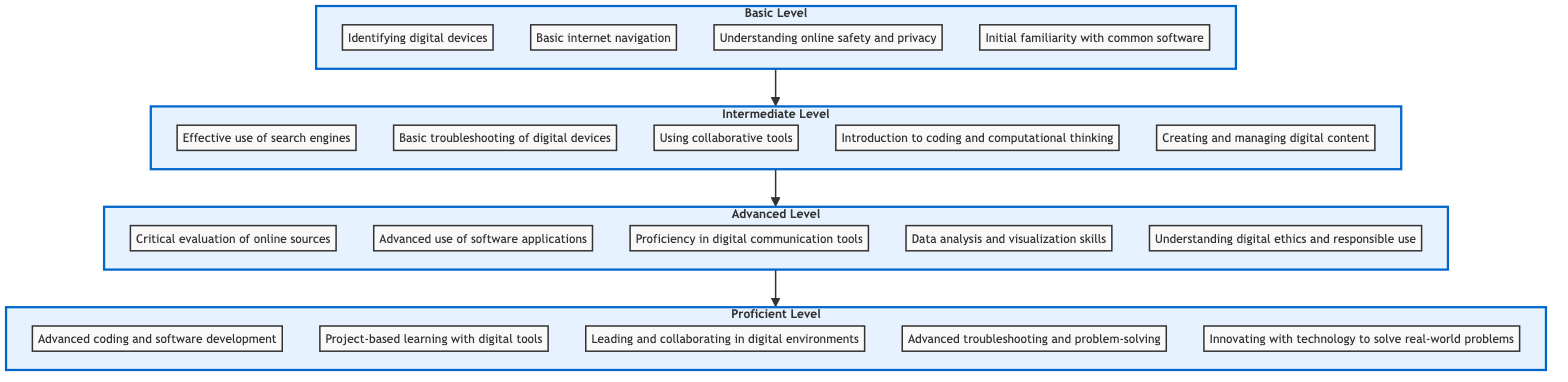What is the lowest level of digital literacy skills in the chart? The lowest level in the flow chart is "Basic", which is depicted at the bottom of the diagram.
Answer: Basic How many skills are listed in the Advanced level? The Advanced level contains five skills, which can be counted directly from the nodes in that section of the diagram.
Answer: 5 Which skills are included in the Intermediate level? The Intermediate level consists of five skills, specifically listed in the diagram as Effective use of search engines, Basic troubleshooting of digital devices, Using collaborative tools, Introduction to coding and computational thinking, and Creating and managing digital content.
Answer: Effective use of search engines, Basic troubleshooting of digital devices, Using collaborative tools, Introduction to coding and computational thinking, Creating and managing digital content What level comes directly before the Proficient level? The level that precedes Proficient, as indicated by the upward arrows connecting the levels, is Advanced.
Answer: Advanced What is the total number of skills listed across all levels? To find the total number of skills, we sum the skills from each level: 4 (Basic) + 5 (Intermediate) + 5 (Advanced) + 5 (Proficient) = 19.
Answer: 19 Which skill focuses on safety and privacy? The skill related to safety and privacy in the Basic level is "Understanding online safety and privacy", as explicitly stated within that section.
Answer: Understanding online safety and privacy How does the flow direction indicate skill progression? The flow direction represents an upward progression, where each level above the lower one signifies an increase in digital literacy skills, illustrating how students progress from Basic to Proficient levels.
Answer: Upward progression Which skill emphasizes collaboration in digital environments? The skill that emphasizes collaboration within digital environments is "Leading and collaborating in digital environments," found in the Proficient level at the top of the chart.
Answer: Leading and collaborating in digital environments What type of skills are primarily focused on problem-solving in the Proficient level? The skills related to problem-solving in the Proficient level include "Advanced troubleshooting and problem-solving" and "Innovating with technology to solve real-world problems," as indicated by the skills listed there.
Answer: Advanced troubleshooting and problem-solving; Innovating with technology to solve real-world problems 